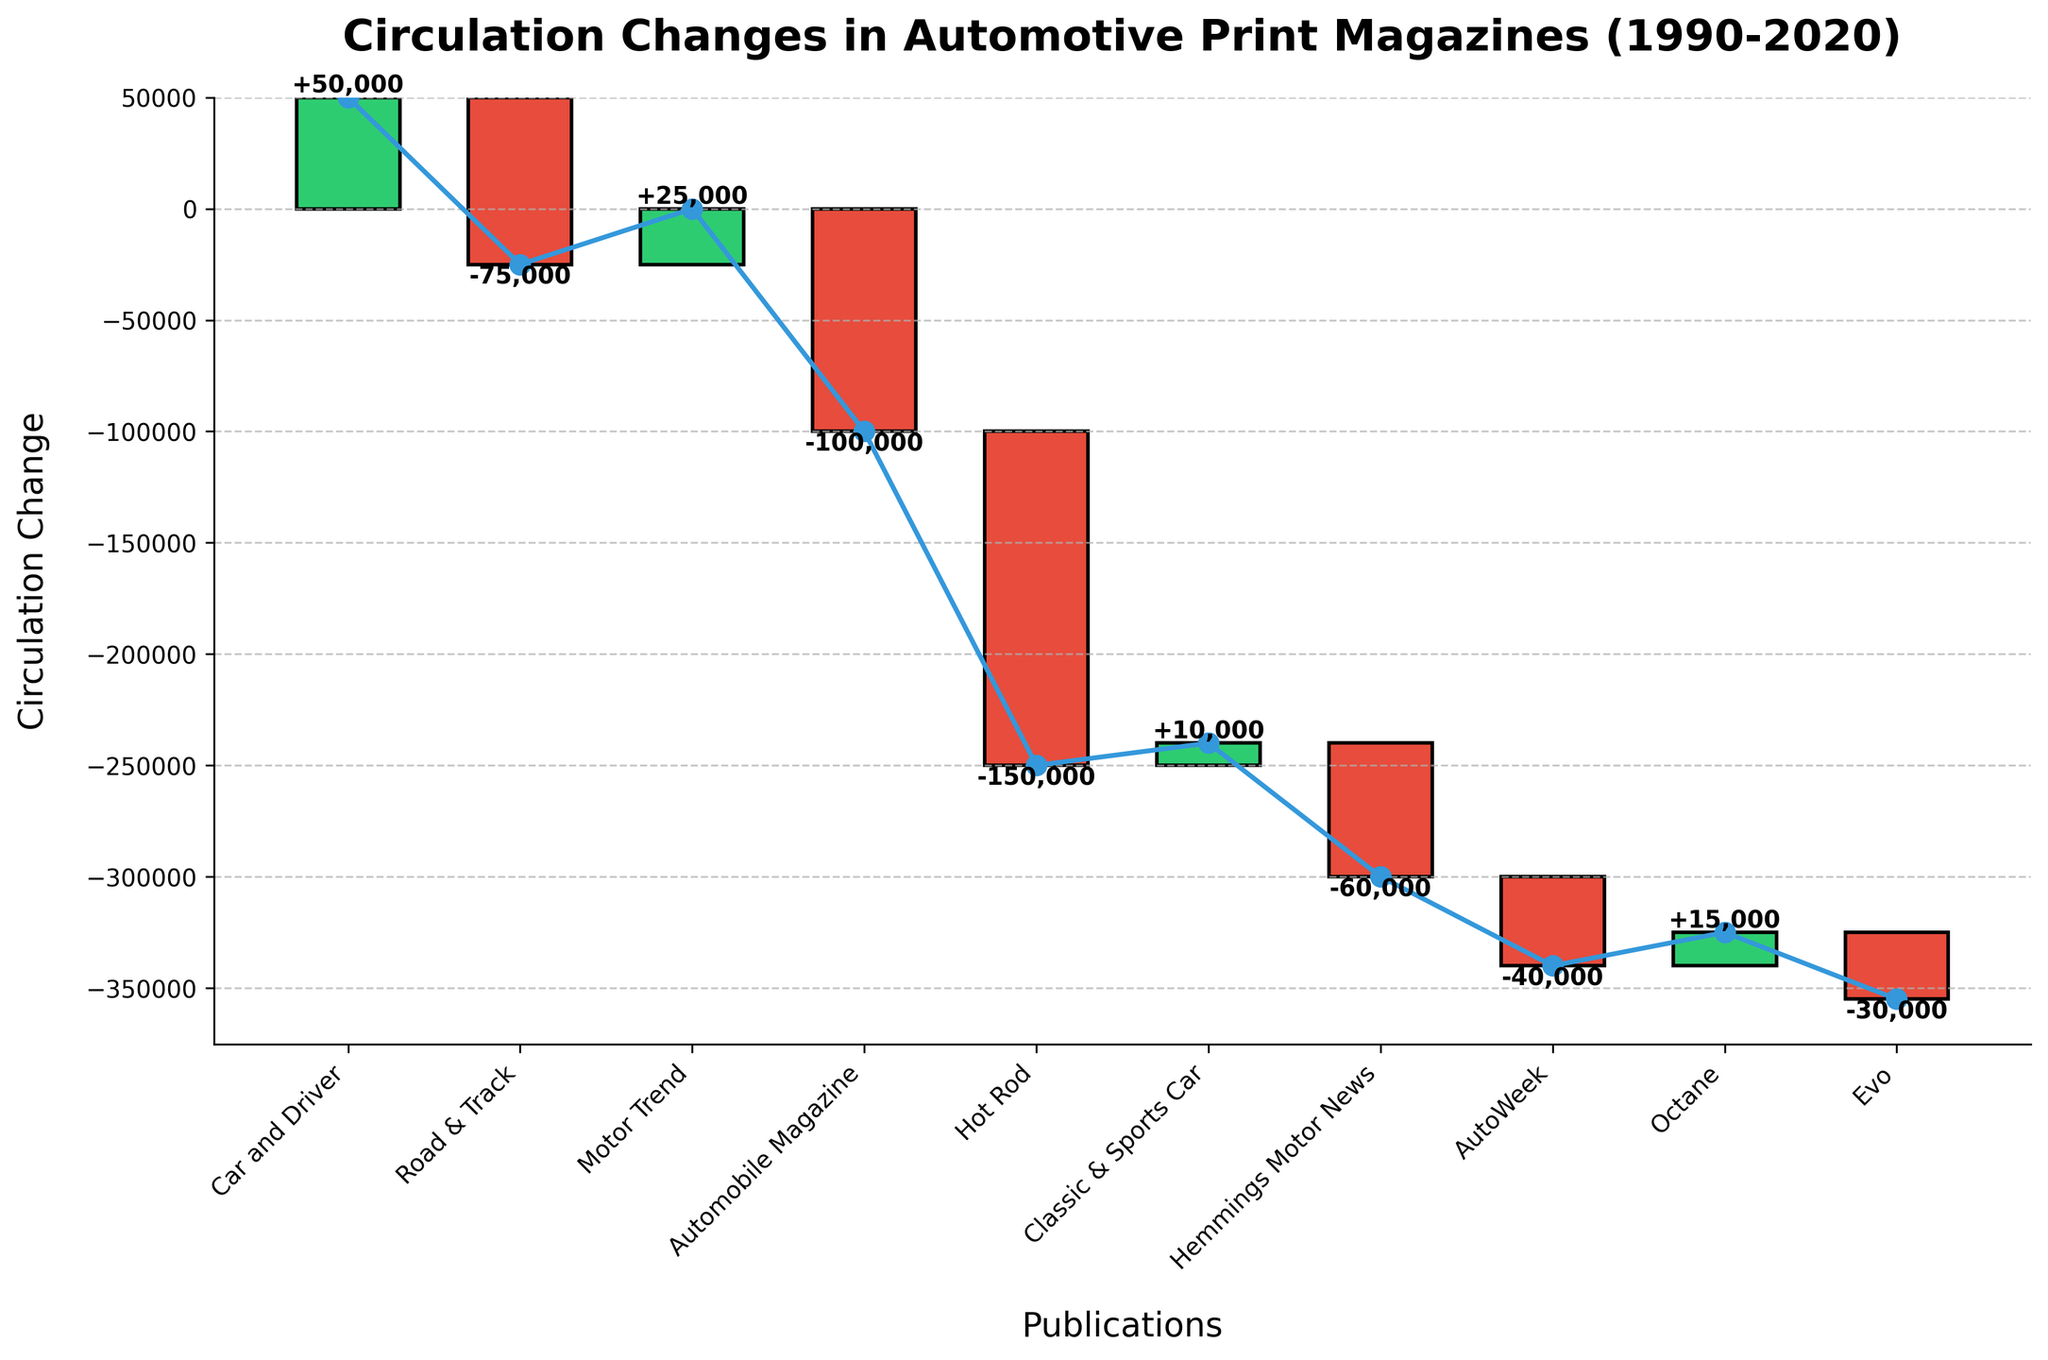Which publication shows the greatest increase in circulation? The publication with the highest positive change can be identified by the tallest green bar, which represents an increase. "Car and Driver" shows the greatest increase in circulation with a +50,000 change
Answer: Car and Driver Which publication experienced the largest decrease in circulation? The publication with the highest negative change is represented by the tallest red bar, indicating a loss. "Hot Rod" shows the largest decrease in circulation with a -150,000 change
Answer: Hot Rod What is the net change in circulation across all publications? To find the net change, sum all the changes of gains and losses: 50000 + (-75000) + 25000 + (-100000) + (-150000) + 10000 + (-60000) + (-40000) + 15000 + (-30000). The net change in circulation across all publications is -240,000
Answer: -240,000 Which publication had a positive change in circulation but less than "Car and Driver"? Identify publications with green bars less than the height of the "Car and Driver" bar. "Motor Trend" and "Classic & Sports Car" had a positive change but less than "Car and Driver" (+50,000) with respective changes of +25,000 and +10,000
Answer: Motor Trend and Classic & Sports Car What is the total increase in circulation among the publications that gained readers? Sum the positive changes: 50,000 (Car and Driver) + 25,000 (Motor Trend) + 10,000 (Classic & Sports Car) + 15,000 (Octane). The total increase is 100,000
Answer: 100,000 Which publications have a circulation change less than zero? Identify publications with red bars indicating a negative change. "Road & Track", "Automobile Magazine", "Hot Rod", "Hemmings Motor News", "AutoWeek", and "Evo" all have circulations less than zero
Answer: Road & Track, Automobile Magazine, Hot Rod, Hemmings Motor News, AutoWeek, and Evo What is the cumulative circulation change after the "Automobile Magazine" publication? The cumulative change after "Automobile Magazine" is calculated as the net sum of the changes up to that point. By that point: 50,000 (Car and Driver) + (-75,000) (Road & Track) + 25,000 (Motor Trend) + (-100,000) (Automobile Magazine) = -100,000
Answer: -100,000 Which publication has the smallest absolute change in circulation? Determine the publication with the smallest bar, either green or red. "Classic & Sports Car" has the smallest change in circulation at +10,000
Answer: Classic & Sports Car 